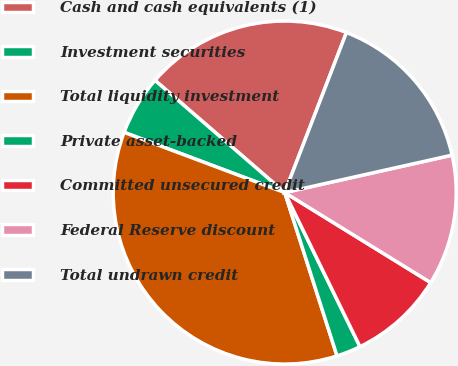Convert chart. <chart><loc_0><loc_0><loc_500><loc_500><pie_chart><fcel>Cash and cash equivalents (1)<fcel>Investment securities<fcel>Total liquidity investment<fcel>Private asset-backed<fcel>Committed unsecured credit<fcel>Federal Reserve discount<fcel>Total undrawn credit<nl><fcel>19.51%<fcel>5.64%<fcel>35.64%<fcel>2.3%<fcel>8.97%<fcel>12.3%<fcel>15.64%<nl></chart> 